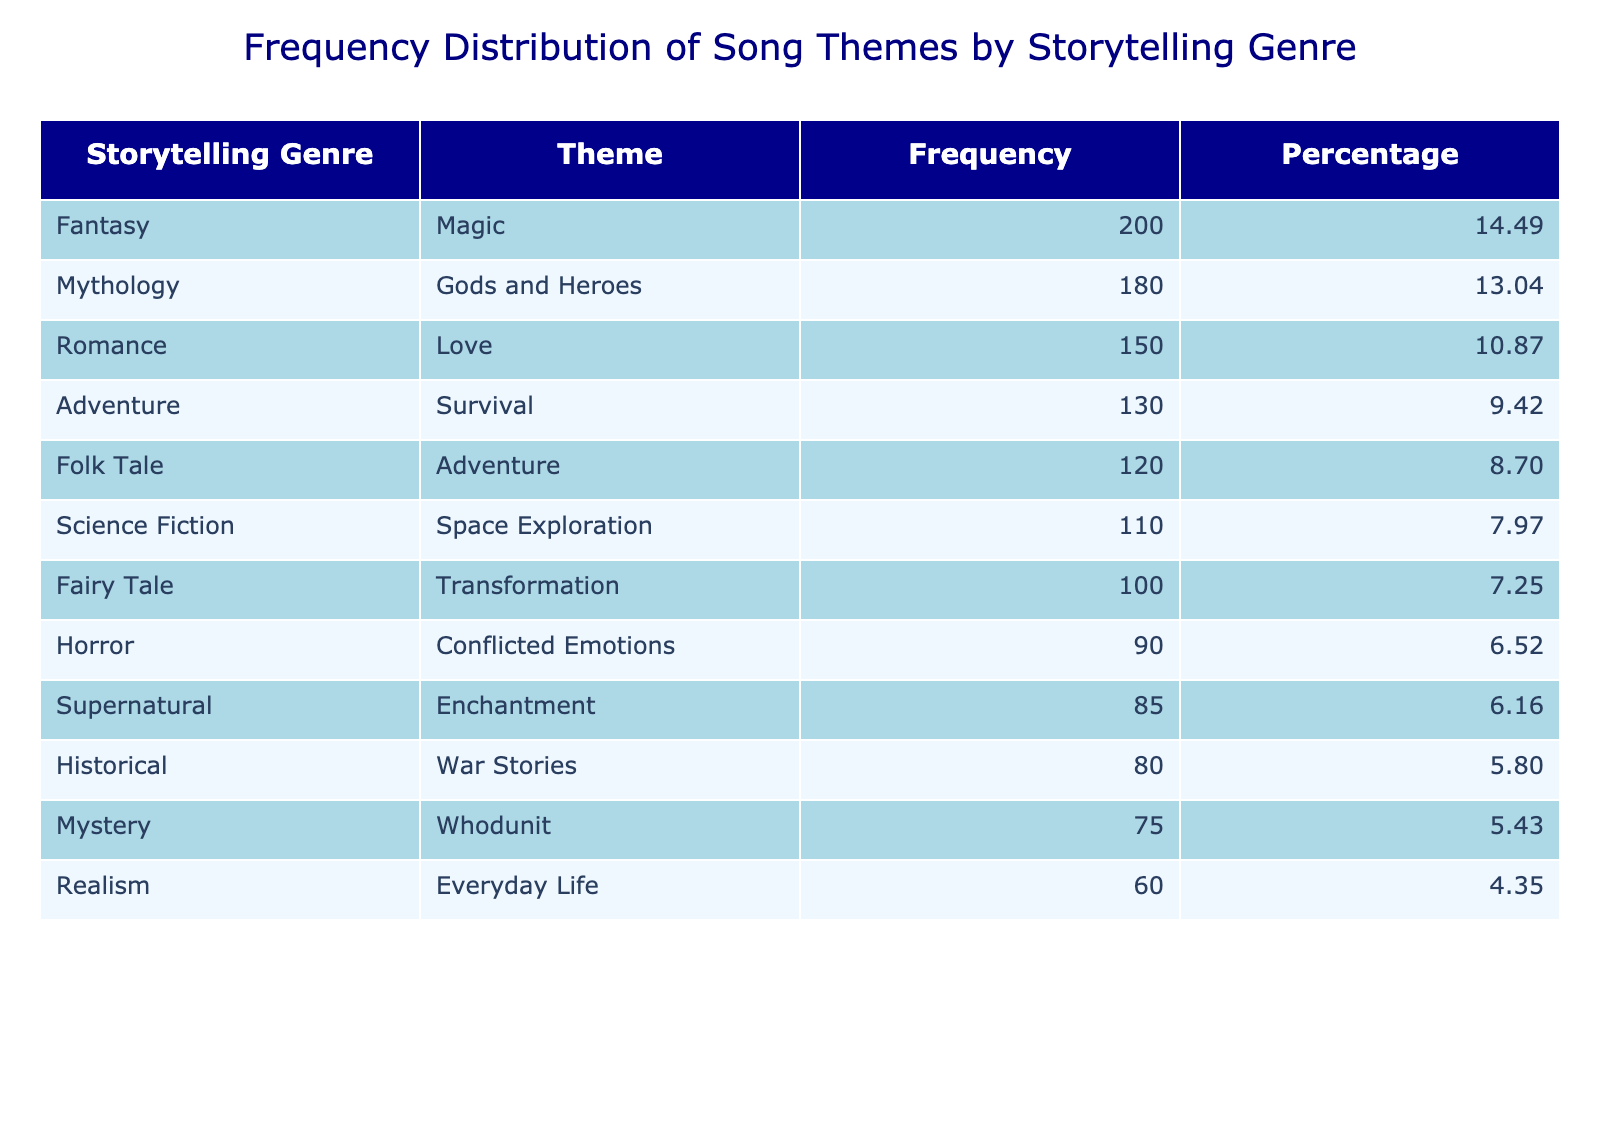What is the most popular theme based on the frequency of songs? Looking at the frequency column in the table, the highest number corresponds to the theme "Magic" under the Fantasy genre, with 200 songs.
Answer: Magic How many songs are themed around Romance? The table indicates that under the Romance genre, there are 150 songs categorized by the theme "Love."
Answer: 150 True or False: The Adventure genre has more songs than the Supernatural genre. The Adventure genre has a total of 120 (Adventure) + 130 (Survival) = 250 songs, while the Supernatural genre has 85 songs. Since 250 > 85, the statement is true.
Answer: True What is the total number of songs for Mythology and Historical genres combined? The Mythology genre has 180 songs (Gods and Heroes) and the Historical genre has 80 songs (War Stories). Adding these together gives 180 + 80 = 260 songs.
Answer: 260 What percentage of songs are centered around the theme of Conflict Emotions compared to the total number of songs? The theme "Conflicted Emotions" under Horror has 90 songs. The total number of songs is 120 + 200 + 150 + 90 + 180 + 110 + 80 + 75 + 130 + 100 + 60 + 85 = 1,010. The percentage is (90/1,010) * 100 = 8.91%.
Answer: 8.91 Which storytelling genre has the least number of songs, and how many does it have? The table shows that the Realism genre has the least number of songs with only 60 categorized under the theme "Everyday Life."
Answer: Realism, 60 If we consider only Fantasy, Horror, and Science Fiction genres, which one has the highest number of songs combined? The Fantasy genre has 200 songs, Horror has 90 songs, and Science Fiction has 110 songs. Adding these gives 200 + 90 + 110 = 400. Fantasy has the highest number of songs among these genres.
Answer: Fantasy How many more songs are themed around Fairy Tales than around Realism themes? The Fairy Tale theme has 100 songs, while the Realism genre has 60 songs. The difference is 100 - 60 = 40 more songs.
Answer: 40 Which theme has a frequency close to the average frequency across all genres? To find the average, sum all frequencies: 1,010 total songs and divide by the number of themes (12), which gives an average of approximately 84.17. The theme "Enchantment" has 85 songs, which is close to the average.
Answer: Enchantment 